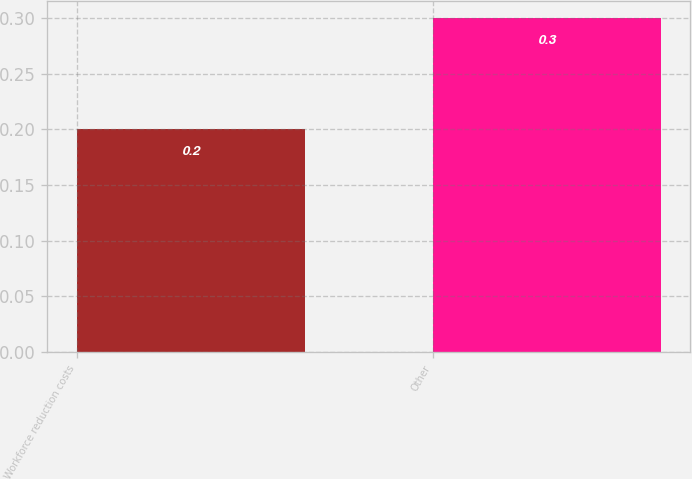Convert chart. <chart><loc_0><loc_0><loc_500><loc_500><bar_chart><fcel>Workforce reduction costs<fcel>Other<nl><fcel>0.2<fcel>0.3<nl></chart> 